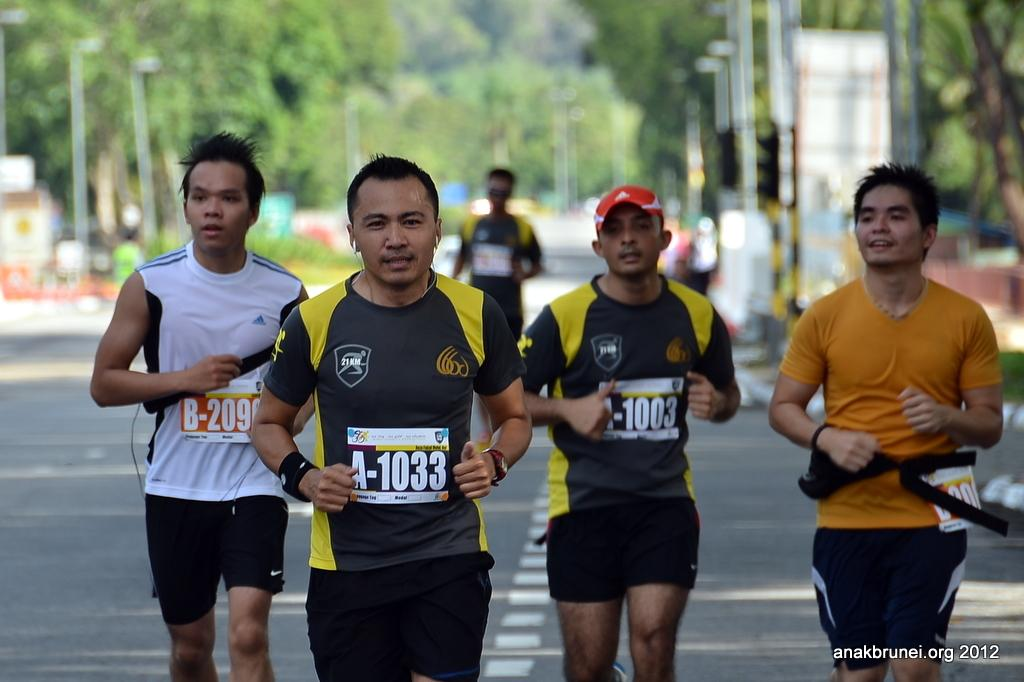What is happening with the group of people in the image? The people are running on the road in the image. What can be seen in the background of the image? There are poles, trees, and hoardings visible in the background of the image. What type of orange is being held by the person in the image? There is no orange present in the image; the people are running on the road. How many cherries can be seen on the trees in the image? There are no cherries visible in the image; there are only trees and hoardings in the background. 